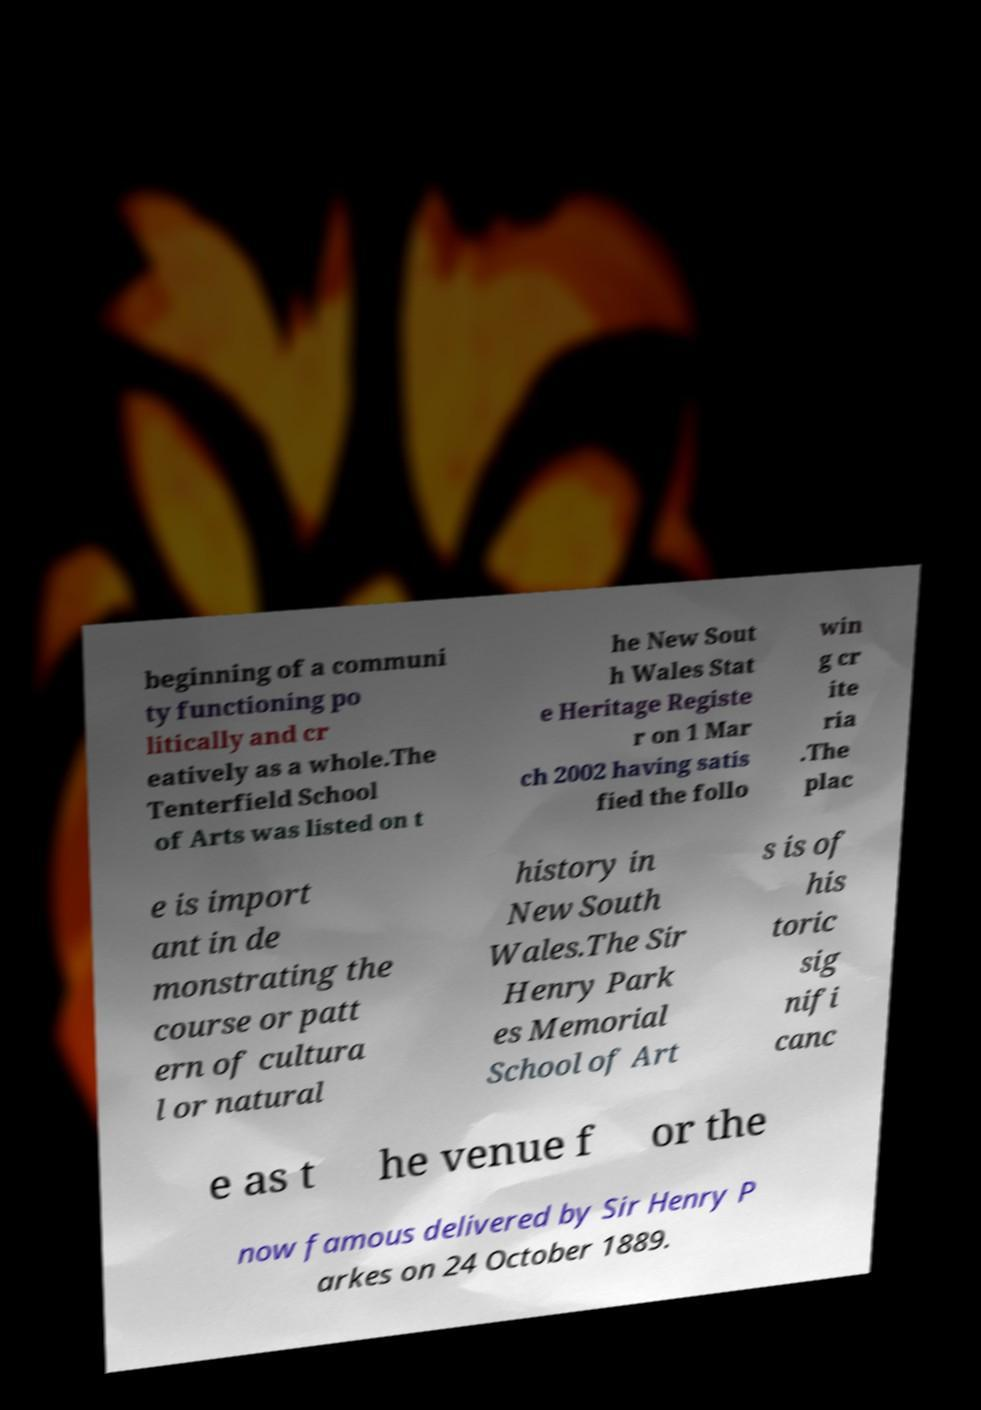Please identify and transcribe the text found in this image. beginning of a communi ty functioning po litically and cr eatively as a whole.The Tenterfield School of Arts was listed on t he New Sout h Wales Stat e Heritage Registe r on 1 Mar ch 2002 having satis fied the follo win g cr ite ria .The plac e is import ant in de monstrating the course or patt ern of cultura l or natural history in New South Wales.The Sir Henry Park es Memorial School of Art s is of his toric sig nifi canc e as t he venue f or the now famous delivered by Sir Henry P arkes on 24 October 1889. 